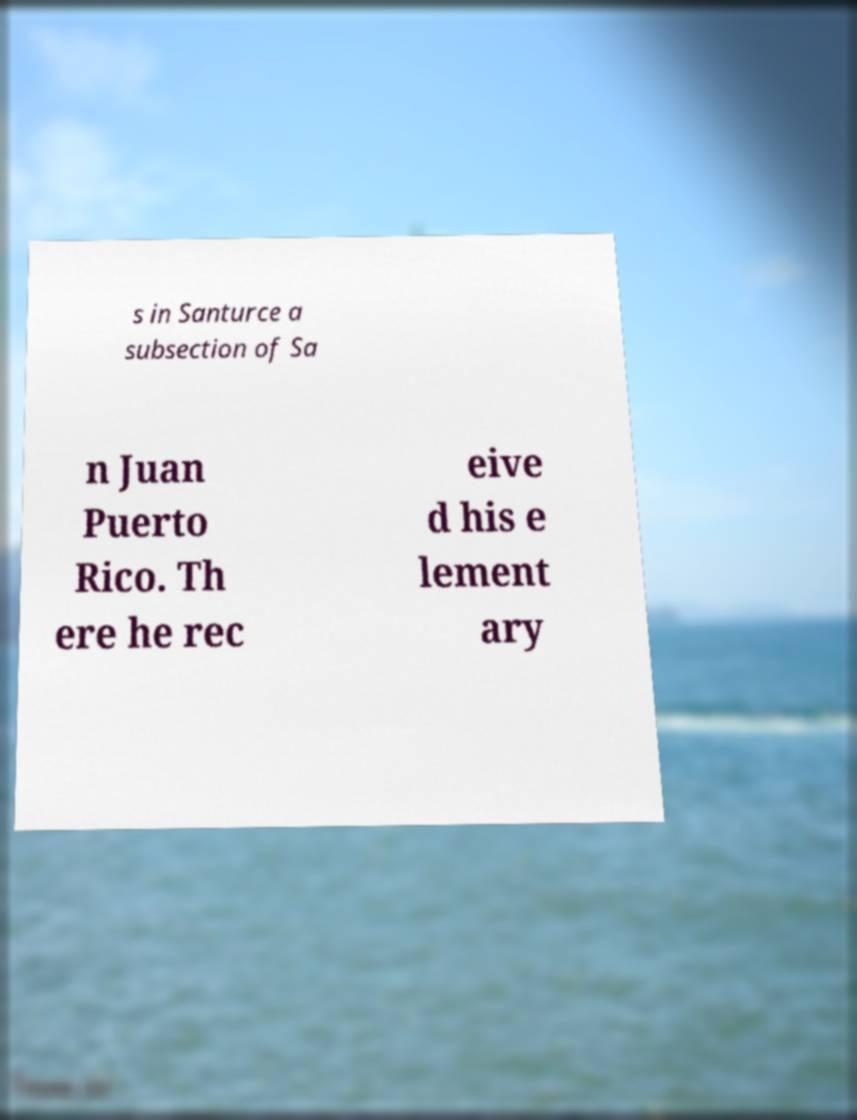There's text embedded in this image that I need extracted. Can you transcribe it verbatim? s in Santurce a subsection of Sa n Juan Puerto Rico. Th ere he rec eive d his e lement ary 